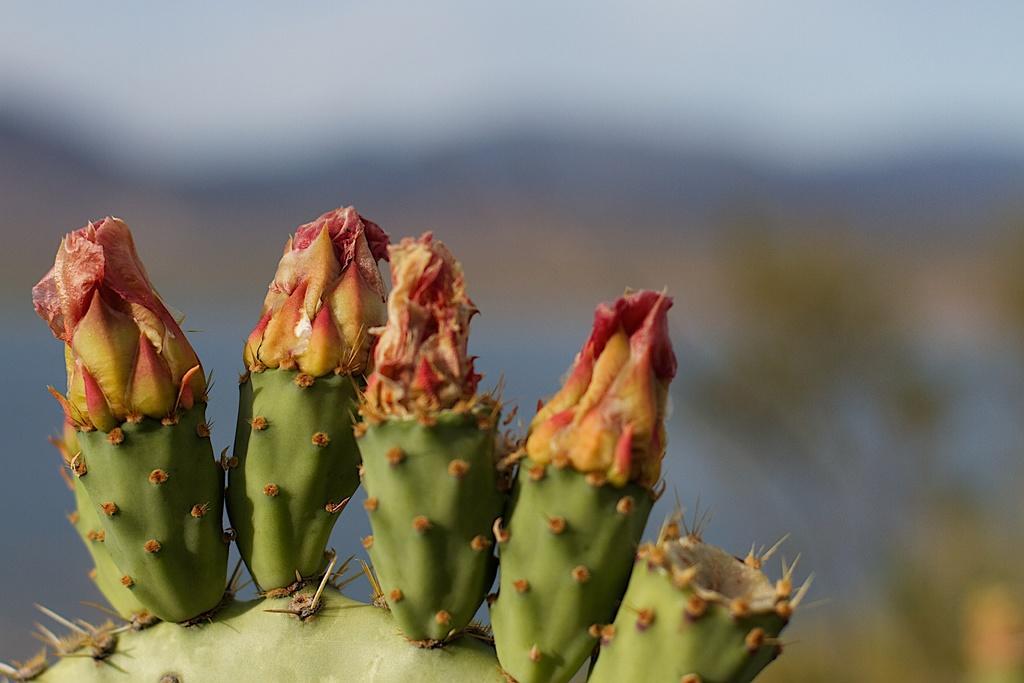Please provide a concise description of this image. In this image there is a cactus plant truncated towards the bottom of the image, the background of the image is blurred. 